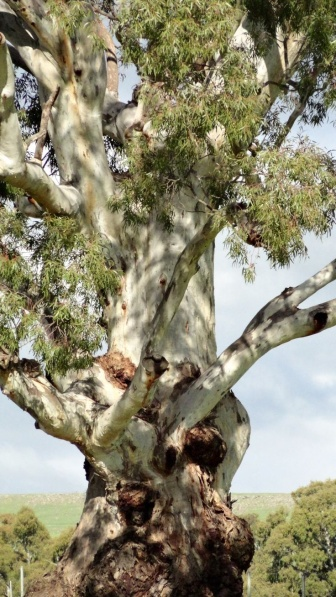Can you elaborate on the elements of the picture provided?
 The image captures a majestic tree standing tall in a serene natural setting. The tree, with its thick trunk and numerous branches, is the central figure in this scene. The bark of the tree is light in color, adorned with patches of green and brown, suggesting a healthy, thriving life. 

One of the striking features of the tree is a large knot or burl on the trunk, with several smaller knots scattered across the branches. These knots, a testament to the tree's age and resilience, add character to its appearance. 

The tree is clothed in a lush canopy of green leaves, providing a stark contrast to the light-colored bark. The leaves, vibrant and full of life, paint a picture of a tree in its prime. 

The tree is set against a backdrop of a clear blue sky and a carpet of green grass, indicating that it is located in a park or a natural area. The blue of the sky and the green of the grass complement the colors of the tree, creating a harmonious and tranquil scene. 

There are no discernible texts or human-made objects in the image, reinforcing the impression of a peaceful, untouched natural environment. The relative positions of the objects in the image - the tree in the foreground, the grass at its base, and the sky in the background - give a sense of depth and perspective to the scene. 

In summary, the image presents a detailed and vivid portrait of a large, robust tree in a natural setting, its features and surroundings described with precision and care. The image is a celebration of nature's beauty and resilience, captured in a single, powerful frame. 